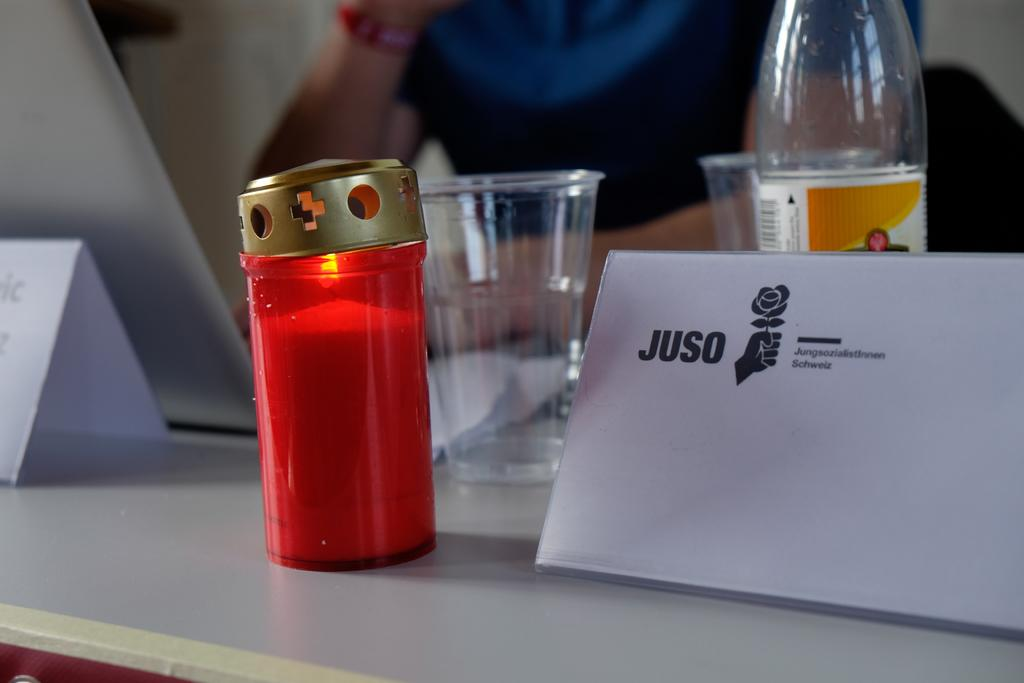<image>
Render a clear and concise summary of the photo. A hand holding a flower is displayed next to the name, "JUSO". 